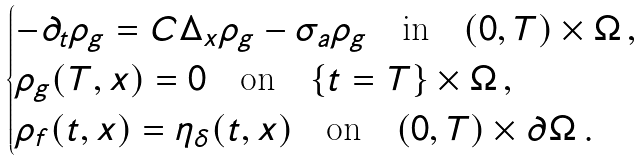<formula> <loc_0><loc_0><loc_500><loc_500>\begin{cases} - \partial _ { t } \rho _ { g } = C \Delta _ { x } \rho _ { g } - \sigma _ { a } \rho _ { g } \quad \text {in} \quad ( 0 , T ) \times \Omega \, , \\ \rho _ { g } ( T , x ) = 0 \quad \text {on} \quad \{ t = T \} \times \Omega \, , \\ \rho _ { f } ( t , x ) = \eta _ { \delta } ( t , x ) \quad \text {on} \quad ( 0 , T ) \times \partial \Omega \, . \end{cases}</formula> 